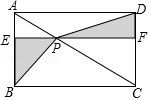Can you explain if there are any symmetrical properties in this image? Yes, the diagram displays symmetry with respect to the diagonal AC. Both triangles, △APD and △BPC, which are formed by this diagonal, are congruent. Moreover, the line segment EF, which creates the two trapezoids, maintains the symmetry as it is parallel to the bases AD and BC of the parallelogram. 